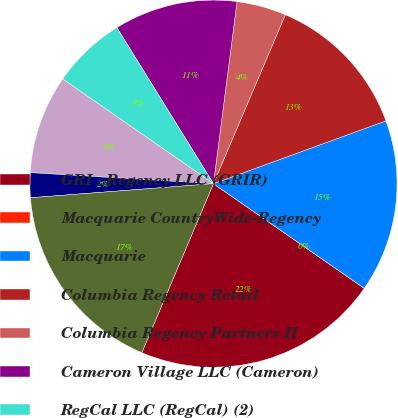Convert chart. <chart><loc_0><loc_0><loc_500><loc_500><pie_chart><fcel>GRI - Regency LLC (GRIR)<fcel>Macquarie CountryWide-Regency<fcel>Macquarie<fcel>Columbia Regency Retail<fcel>Columbia Regency Partners II<fcel>Cameron Village LLC (Cameron)<fcel>RegCal LLC (RegCal) (2)<fcel>Regency Retail Partners LP<fcel>US Regency Retail I LLC (USAA)<fcel>Other investments in real<nl><fcel>21.73%<fcel>0.0%<fcel>15.21%<fcel>13.04%<fcel>4.35%<fcel>10.87%<fcel>6.52%<fcel>8.7%<fcel>2.18%<fcel>17.39%<nl></chart> 